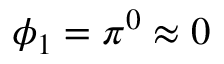Convert formula to latex. <formula><loc_0><loc_0><loc_500><loc_500>\phi _ { 1 } = \pi ^ { 0 } \approx 0</formula> 